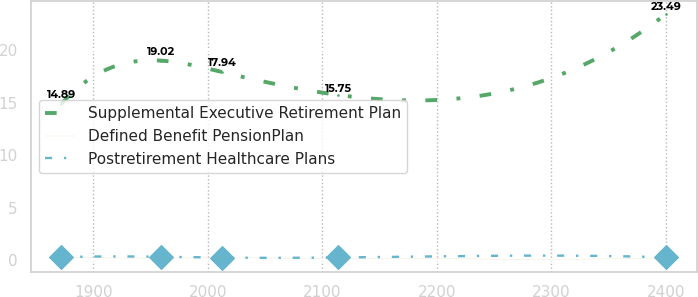<chart> <loc_0><loc_0><loc_500><loc_500><line_chart><ecel><fcel>Supplemental Executive Retirement Plan<fcel>Defined Benefit PensionPlan<fcel>Postretirement Healthcare Plans<nl><fcel>1871.92<fcel>14.89<fcel>0.25<fcel>0.28<nl><fcel>1959.28<fcel>19.02<fcel>0.21<fcel>0.33<nl><fcel>2012.13<fcel>17.94<fcel>0.22<fcel>0.25<nl><fcel>2113.78<fcel>15.75<fcel>0.18<fcel>0.26<nl><fcel>2400.38<fcel>23.49<fcel>0.2<fcel>0.27<nl></chart> 